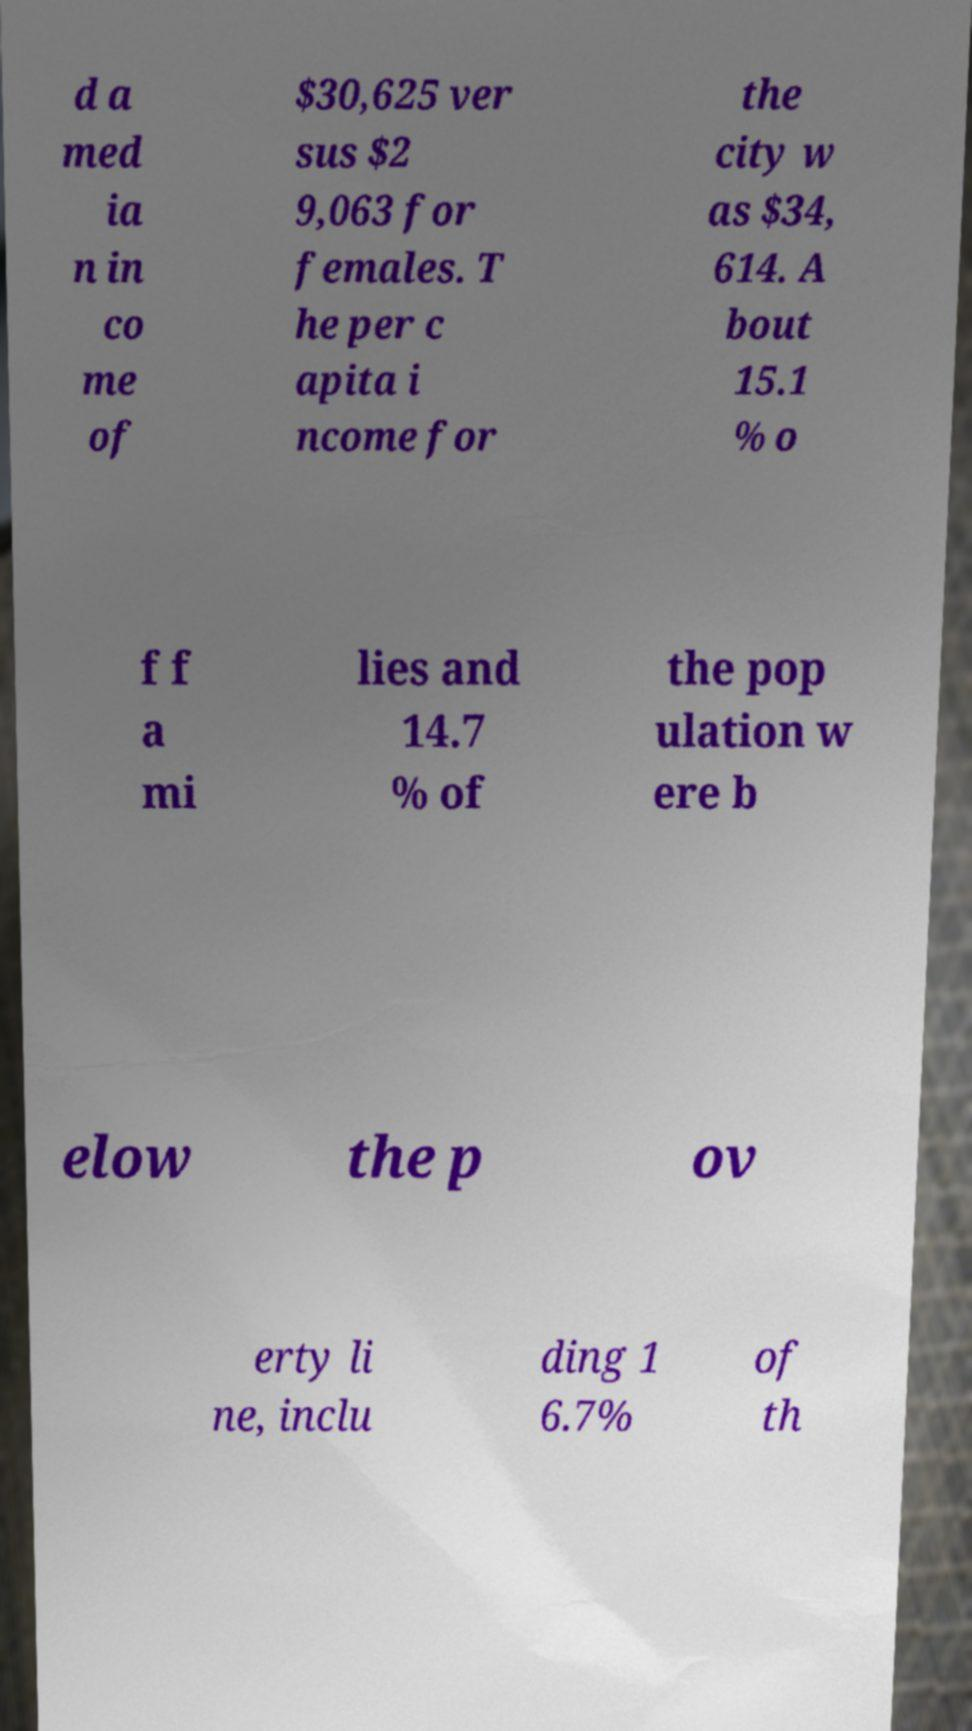Please read and relay the text visible in this image. What does it say? d a med ia n in co me of $30,625 ver sus $2 9,063 for females. T he per c apita i ncome for the city w as $34, 614. A bout 15.1 % o f f a mi lies and 14.7 % of the pop ulation w ere b elow the p ov erty li ne, inclu ding 1 6.7% of th 